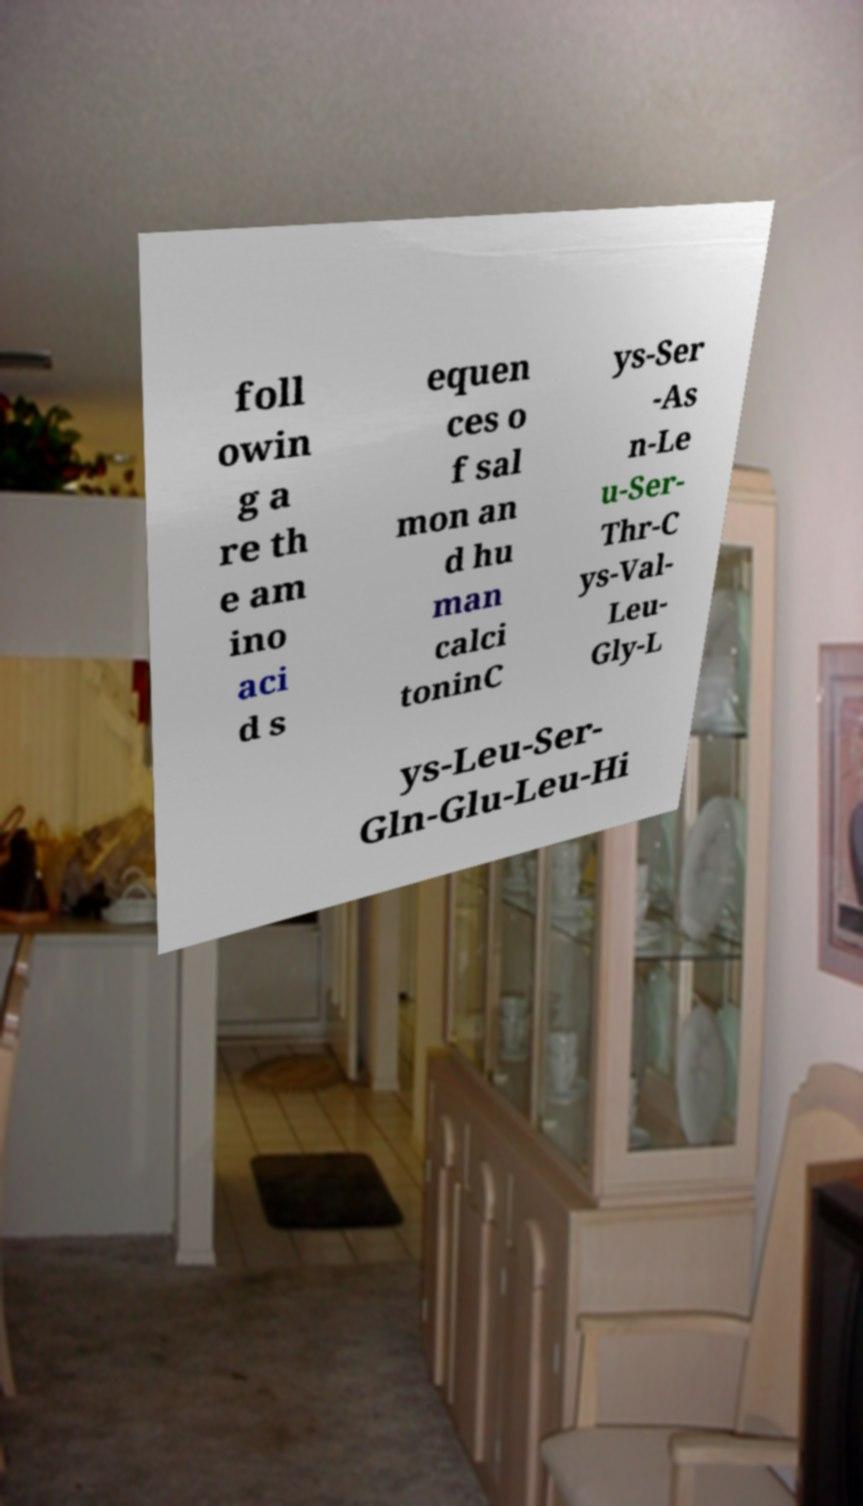Please identify and transcribe the text found in this image. foll owin g a re th e am ino aci d s equen ces o f sal mon an d hu man calci toninC ys-Ser -As n-Le u-Ser- Thr-C ys-Val- Leu- Gly-L ys-Leu-Ser- Gln-Glu-Leu-Hi 